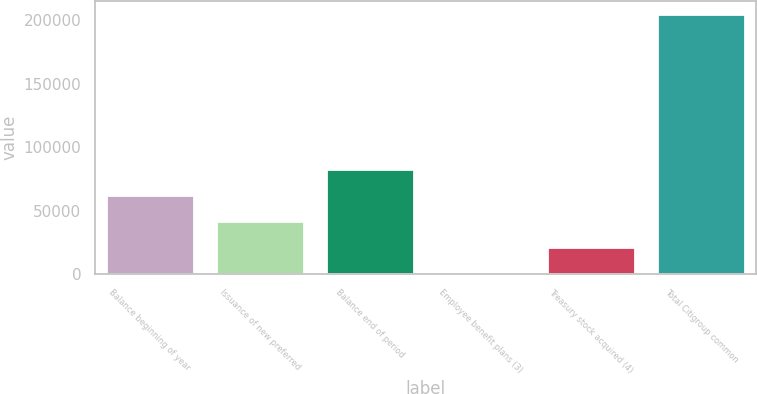Convert chart to OTSL. <chart><loc_0><loc_0><loc_500><loc_500><bar_chart><fcel>Balance beginning of year<fcel>Issuance of new preferred<fcel>Balance end of period<fcel>Employee benefit plans (3)<fcel>Treasury stock acquired (4)<fcel>Total Citigroup common<nl><fcel>62034.5<fcel>41591<fcel>82478<fcel>704<fcel>21147.5<fcel>205139<nl></chart> 